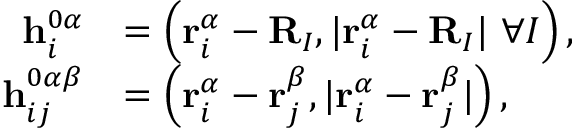Convert formula to latex. <formula><loc_0><loc_0><loc_500><loc_500>\begin{array} { r l } { h _ { i } ^ { 0 \alpha } } & { = \left ( r _ { i } ^ { \alpha } - R _ { I } , | r _ { i } ^ { \alpha } - R _ { I } | \ \forall I \right ) , } \\ { h _ { i j } ^ { 0 \alpha \beta } } & { = \left ( r _ { i } ^ { \alpha } - r _ { j } ^ { \beta } , | r _ { i } ^ { \alpha } - r _ { j } ^ { \beta } | \right ) , } \end{array}</formula> 